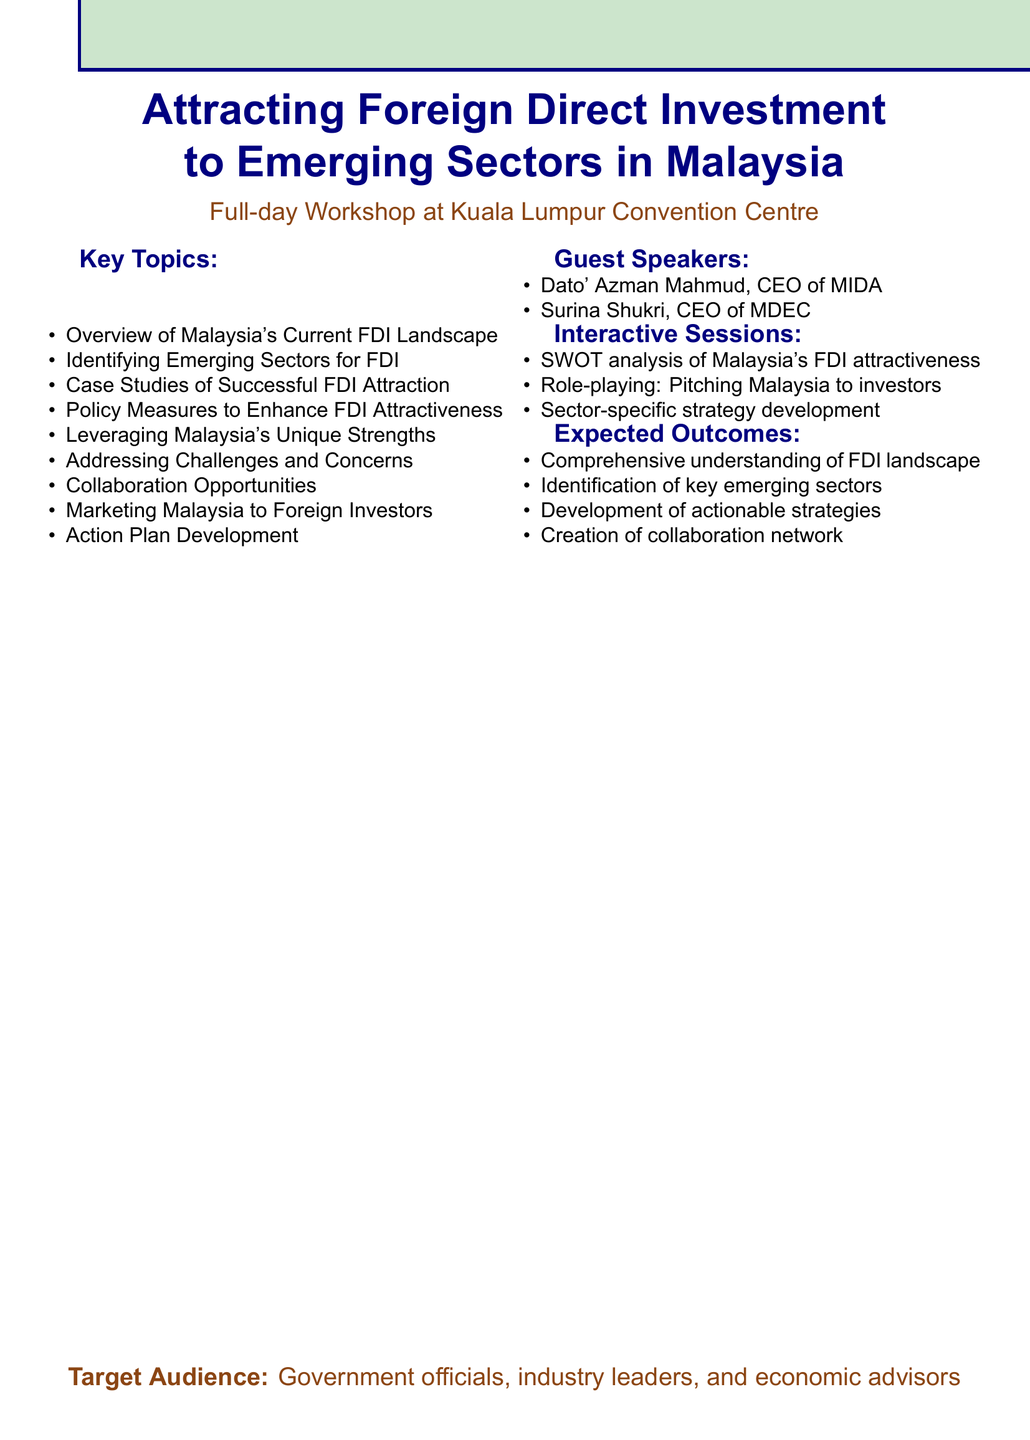What is the workshop title? The workshop title is stated at the top of the document under the heading.
Answer: Attracting Foreign Direct Investment to Emerging Sectors in Malaysia What is the venue for the workshop? The venue is indicated in the document as the location of the workshop.
Answer: Kuala Lumpur Convention Centre Who is the CEO of MIDA? This information can be found in the guest speakers section, which lists their names and positions.
Answer: Dato' Azman Mahmud Which emerging sector involves renewable energy? This is a subtopic listed in the key topics section regarding emerging sectors for FDI.
Answer: Renewable energy and green technology What are the expected outcomes of the workshop? The expected outcomes are listed in a distinct section of the document, making them easily identifiable.
Answer: Comprehensive understanding of Malaysia's FDI landscape How many guest speakers are mentioned in the document? The number of guest speakers is derived from counting the individual speakers listed.
Answer: 2 What interactive session involves a SWOT analysis? This details the interactive activities listed in the document that participants will engage in during the workshop.
Answer: SWOT analysis of Malaysia's FDI attractiveness What is the duration of the workshop? The duration is specified in the document to clarify how long the event will last.
Answer: Full-day workshop 